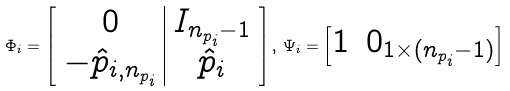Convert formula to latex. <formula><loc_0><loc_0><loc_500><loc_500>\Phi _ { i } = \left [ \begin{array} { c | c } 0 & I _ { n _ { p _ { i } } - 1 } \\ - \hat { p } _ { i , n _ { p _ { i } } } & \hat { p } _ { i } \end{array} \right ] , \, \Psi _ { i } = \begin{bmatrix} 1 & 0 _ { 1 \times ( n _ { p _ { i } } - 1 ) } \end{bmatrix}</formula> 